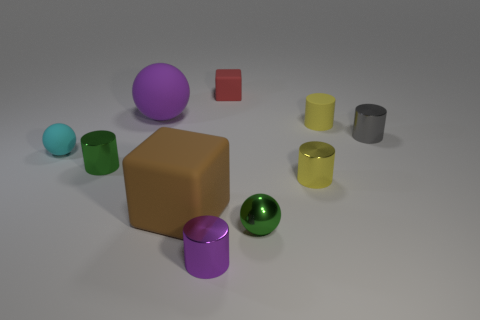There is a small object that is the same color as the tiny shiny sphere; what is its shape?
Your answer should be very brief. Cylinder. How many blocks are either tiny red objects or big purple things?
Provide a short and direct response. 1. There is a small sphere in front of the tiny green thing to the left of the purple rubber object; what color is it?
Keep it short and to the point. Green. There is a large ball; is its color the same as the metallic cylinder in front of the brown object?
Ensure brevity in your answer.  Yes. What is the size of the cube that is made of the same material as the small red object?
Your answer should be compact. Large. There is a purple thing behind the ball in front of the small yellow shiny cylinder; is there a tiny metal cylinder that is right of it?
Your answer should be very brief. Yes. What number of other objects are the same size as the brown thing?
Your answer should be very brief. 1. There is a yellow object in front of the tiny gray shiny cylinder; is its size the same as the cylinder to the left of the brown rubber cube?
Provide a short and direct response. Yes. The small matte object that is in front of the small red rubber object and behind the tiny cyan rubber object has what shape?
Provide a short and direct response. Cylinder. Are there any tiny things that have the same color as the big rubber ball?
Provide a short and direct response. Yes. 